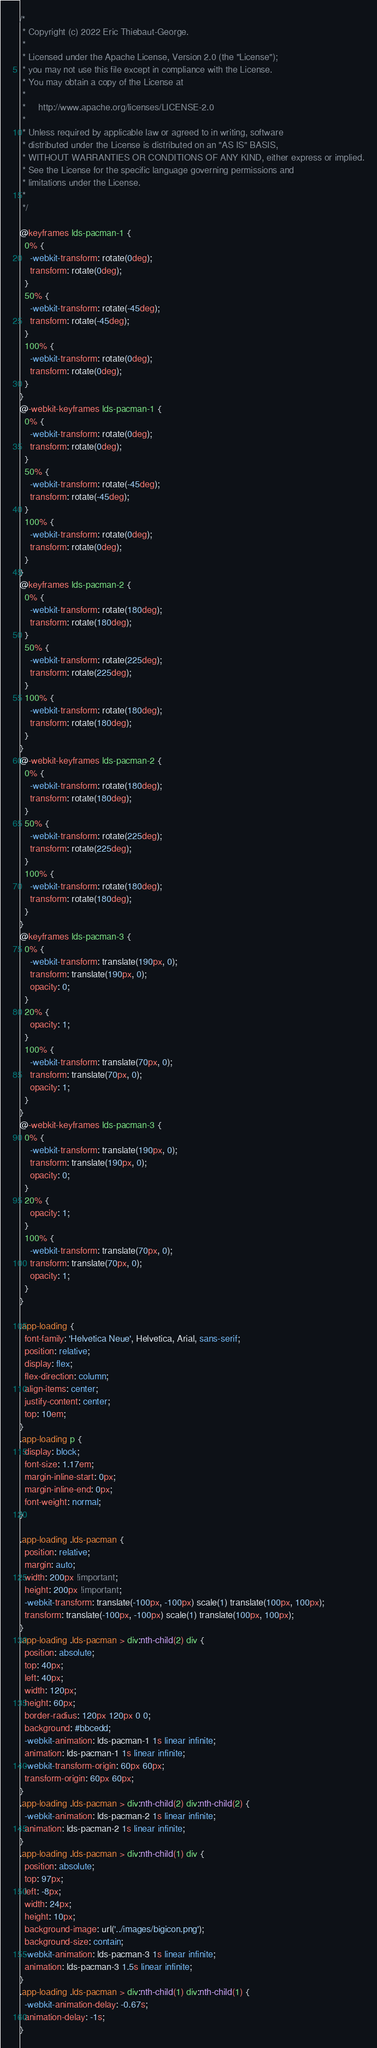<code> <loc_0><loc_0><loc_500><loc_500><_CSS_>/*
 * Copyright (c) 2022 Eric Thiebaut-George.
 *
 * Licensed under the Apache License, Version 2.0 (the "License");
 * you may not use this file except in compliance with the License.
 * You may obtain a copy of the License at
 *
 *     http://www.apache.org/licenses/LICENSE-2.0
 *
 * Unless required by applicable law or agreed to in writing, software
 * distributed under the License is distributed on an "AS IS" BASIS,
 * WITHOUT WARRANTIES OR CONDITIONS OF ANY KIND, either express or implied.
 * See the License for the specific language governing permissions and
 * limitations under the License.
 *
 */

@keyframes lds-pacman-1 {
  0% {
    -webkit-transform: rotate(0deg);
    transform: rotate(0deg);
  }
  50% {
    -webkit-transform: rotate(-45deg);
    transform: rotate(-45deg);
  }
  100% {
    -webkit-transform: rotate(0deg);
    transform: rotate(0deg);
  }
}
@-webkit-keyframes lds-pacman-1 {
  0% {
    -webkit-transform: rotate(0deg);
    transform: rotate(0deg);
  }
  50% {
    -webkit-transform: rotate(-45deg);
    transform: rotate(-45deg);
  }
  100% {
    -webkit-transform: rotate(0deg);
    transform: rotate(0deg);
  }
}
@keyframes lds-pacman-2 {
  0% {
    -webkit-transform: rotate(180deg);
    transform: rotate(180deg);
  }
  50% {
    -webkit-transform: rotate(225deg);
    transform: rotate(225deg);
  }
  100% {
    -webkit-transform: rotate(180deg);
    transform: rotate(180deg);
  }
}
@-webkit-keyframes lds-pacman-2 {
  0% {
    -webkit-transform: rotate(180deg);
    transform: rotate(180deg);
  }
  50% {
    -webkit-transform: rotate(225deg);
    transform: rotate(225deg);
  }
  100% {
    -webkit-transform: rotate(180deg);
    transform: rotate(180deg);
  }
}
@keyframes lds-pacman-3 {
  0% {
    -webkit-transform: translate(190px, 0);
    transform: translate(190px, 0);
    opacity: 0;
  }
  20% {
    opacity: 1;
  }
  100% {
    -webkit-transform: translate(70px, 0);
    transform: translate(70px, 0);
    opacity: 1;
  }
}
@-webkit-keyframes lds-pacman-3 {
  0% {
    -webkit-transform: translate(190px, 0);
    transform: translate(190px, 0);
    opacity: 0;
  }
  20% {
    opacity: 1;
  }
  100% {
    -webkit-transform: translate(70px, 0);
    transform: translate(70px, 0);
    opacity: 1;
  }
}

.app-loading {
  font-family: 'Helvetica Neue', Helvetica, Arial, sans-serif;
  position: relative;
  display: flex;
  flex-direction: column;
  align-items: center;
  justify-content: center;
  top: 10em;
}
.app-loading p {
  display: block;
  font-size: 1.17em;
  margin-inline-start: 0px;
  margin-inline-end: 0px;
  font-weight: normal;
}

.app-loading .lds-pacman {
  position: relative;
  margin: auto;
  width: 200px !important;
  height: 200px !important;
  -webkit-transform: translate(-100px, -100px) scale(1) translate(100px, 100px);
  transform: translate(-100px, -100px) scale(1) translate(100px, 100px);
}
.app-loading .lds-pacman > div:nth-child(2) div {
  position: absolute;
  top: 40px;
  left: 40px;
  width: 120px;
  height: 60px;
  border-radius: 120px 120px 0 0;
  background: #bbcedd;
  -webkit-animation: lds-pacman-1 1s linear infinite;
  animation: lds-pacman-1 1s linear infinite;
  -webkit-transform-origin: 60px 60px;
  transform-origin: 60px 60px;
}
.app-loading .lds-pacman > div:nth-child(2) div:nth-child(2) {
  -webkit-animation: lds-pacman-2 1s linear infinite;
  animation: lds-pacman-2 1s linear infinite;
}
.app-loading .lds-pacman > div:nth-child(1) div {
  position: absolute;
  top: 97px;
  left: -8px;
  width: 24px;
  height: 10px;
  background-image: url('../images/bigicon.png');
  background-size: contain;
  -webkit-animation: lds-pacman-3 1s linear infinite;
  animation: lds-pacman-3 1.5s linear infinite;
}
.app-loading .lds-pacman > div:nth-child(1) div:nth-child(1) {
  -webkit-animation-delay: -0.67s;
  animation-delay: -1s;
}</code> 